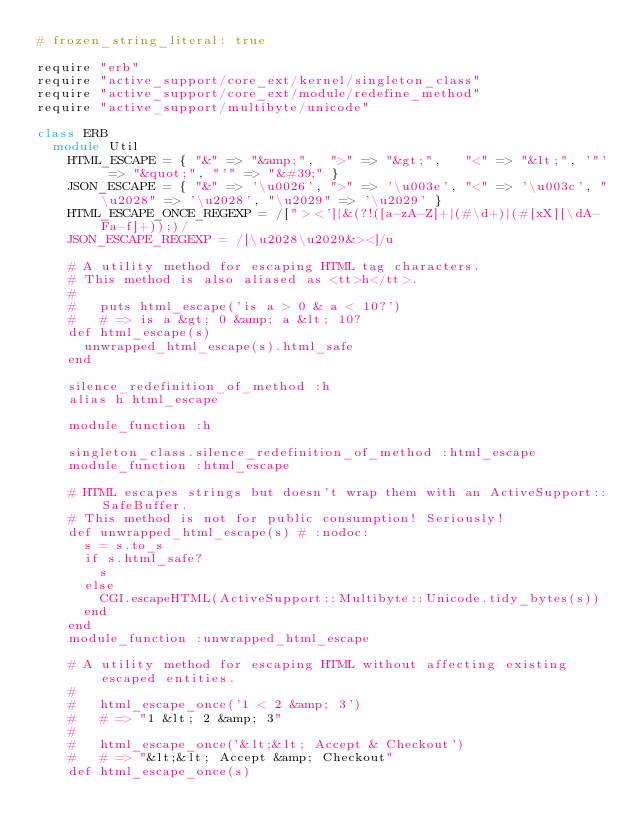<code> <loc_0><loc_0><loc_500><loc_500><_Ruby_># frozen_string_literal: true

require "erb"
require "active_support/core_ext/kernel/singleton_class"
require "active_support/core_ext/module/redefine_method"
require "active_support/multibyte/unicode"

class ERB
  module Util
    HTML_ESCAPE = { "&" => "&amp;",  ">" => "&gt;",   "<" => "&lt;", '"' => "&quot;", "'" => "&#39;" }
    JSON_ESCAPE = { "&" => '\u0026', ">" => '\u003e', "<" => '\u003c', "\u2028" => '\u2028', "\u2029" => '\u2029' }
    HTML_ESCAPE_ONCE_REGEXP = /["><']|&(?!([a-zA-Z]+|(#\d+)|(#[xX][\dA-Fa-f]+));)/
    JSON_ESCAPE_REGEXP = /[\u2028\u2029&><]/u

    # A utility method for escaping HTML tag characters.
    # This method is also aliased as <tt>h</tt>.
    #
    #   puts html_escape('is a > 0 & a < 10?')
    #   # => is a &gt; 0 &amp; a &lt; 10?
    def html_escape(s)
      unwrapped_html_escape(s).html_safe
    end

    silence_redefinition_of_method :h
    alias h html_escape

    module_function :h

    singleton_class.silence_redefinition_of_method :html_escape
    module_function :html_escape

    # HTML escapes strings but doesn't wrap them with an ActiveSupport::SafeBuffer.
    # This method is not for public consumption! Seriously!
    def unwrapped_html_escape(s) # :nodoc:
      s = s.to_s
      if s.html_safe?
        s
      else
        CGI.escapeHTML(ActiveSupport::Multibyte::Unicode.tidy_bytes(s))
      end
    end
    module_function :unwrapped_html_escape

    # A utility method for escaping HTML without affecting existing escaped entities.
    #
    #   html_escape_once('1 < 2 &amp; 3')
    #   # => "1 &lt; 2 &amp; 3"
    #
    #   html_escape_once('&lt;&lt; Accept & Checkout')
    #   # => "&lt;&lt; Accept &amp; Checkout"
    def html_escape_once(s)</code> 